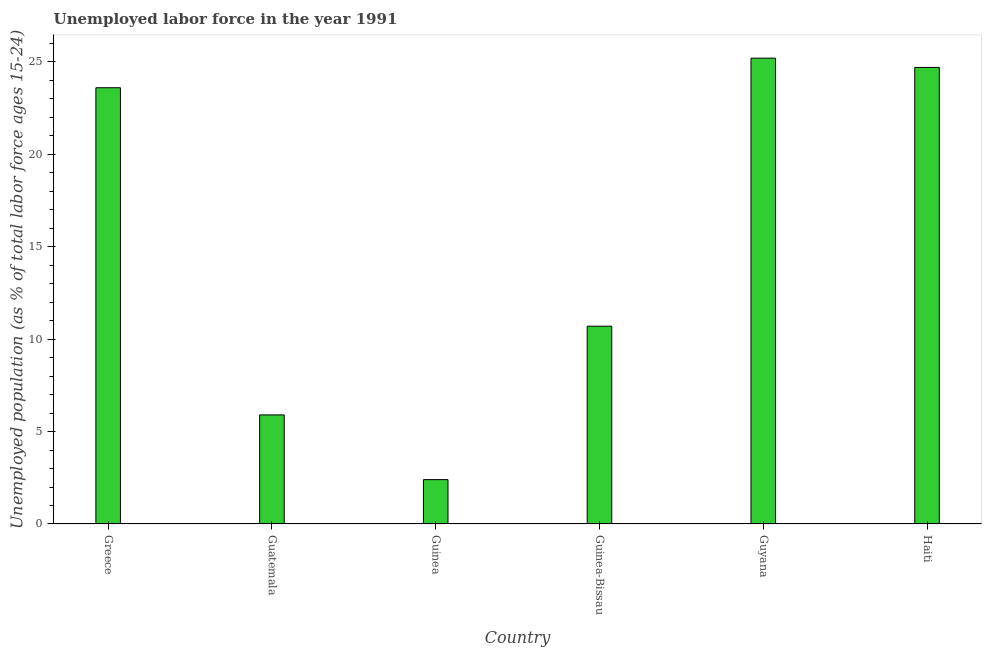Does the graph contain any zero values?
Make the answer very short. No. What is the title of the graph?
Make the answer very short. Unemployed labor force in the year 1991. What is the label or title of the Y-axis?
Provide a short and direct response. Unemployed population (as % of total labor force ages 15-24). What is the total unemployed youth population in Greece?
Make the answer very short. 23.6. Across all countries, what is the maximum total unemployed youth population?
Your answer should be very brief. 25.2. Across all countries, what is the minimum total unemployed youth population?
Your answer should be compact. 2.4. In which country was the total unemployed youth population maximum?
Give a very brief answer. Guyana. In which country was the total unemployed youth population minimum?
Make the answer very short. Guinea. What is the sum of the total unemployed youth population?
Keep it short and to the point. 92.5. What is the difference between the total unemployed youth population in Guyana and Haiti?
Keep it short and to the point. 0.5. What is the average total unemployed youth population per country?
Offer a terse response. 15.42. What is the median total unemployed youth population?
Give a very brief answer. 17.15. In how many countries, is the total unemployed youth population greater than 15 %?
Make the answer very short. 3. Is the sum of the total unemployed youth population in Guinea-Bissau and Haiti greater than the maximum total unemployed youth population across all countries?
Provide a succinct answer. Yes. What is the difference between the highest and the lowest total unemployed youth population?
Keep it short and to the point. 22.8. In how many countries, is the total unemployed youth population greater than the average total unemployed youth population taken over all countries?
Your answer should be very brief. 3. How many bars are there?
Keep it short and to the point. 6. Are all the bars in the graph horizontal?
Your response must be concise. No. What is the difference between two consecutive major ticks on the Y-axis?
Provide a short and direct response. 5. What is the Unemployed population (as % of total labor force ages 15-24) of Greece?
Ensure brevity in your answer.  23.6. What is the Unemployed population (as % of total labor force ages 15-24) in Guatemala?
Offer a terse response. 5.9. What is the Unemployed population (as % of total labor force ages 15-24) in Guinea?
Make the answer very short. 2.4. What is the Unemployed population (as % of total labor force ages 15-24) of Guinea-Bissau?
Give a very brief answer. 10.7. What is the Unemployed population (as % of total labor force ages 15-24) in Guyana?
Your response must be concise. 25.2. What is the Unemployed population (as % of total labor force ages 15-24) of Haiti?
Ensure brevity in your answer.  24.7. What is the difference between the Unemployed population (as % of total labor force ages 15-24) in Greece and Guinea?
Your answer should be very brief. 21.2. What is the difference between the Unemployed population (as % of total labor force ages 15-24) in Greece and Guinea-Bissau?
Keep it short and to the point. 12.9. What is the difference between the Unemployed population (as % of total labor force ages 15-24) in Greece and Haiti?
Provide a short and direct response. -1.1. What is the difference between the Unemployed population (as % of total labor force ages 15-24) in Guatemala and Guinea-Bissau?
Ensure brevity in your answer.  -4.8. What is the difference between the Unemployed population (as % of total labor force ages 15-24) in Guatemala and Guyana?
Keep it short and to the point. -19.3. What is the difference between the Unemployed population (as % of total labor force ages 15-24) in Guatemala and Haiti?
Provide a short and direct response. -18.8. What is the difference between the Unemployed population (as % of total labor force ages 15-24) in Guinea and Guinea-Bissau?
Make the answer very short. -8.3. What is the difference between the Unemployed population (as % of total labor force ages 15-24) in Guinea and Guyana?
Your answer should be very brief. -22.8. What is the difference between the Unemployed population (as % of total labor force ages 15-24) in Guinea and Haiti?
Provide a succinct answer. -22.3. What is the difference between the Unemployed population (as % of total labor force ages 15-24) in Guyana and Haiti?
Make the answer very short. 0.5. What is the ratio of the Unemployed population (as % of total labor force ages 15-24) in Greece to that in Guinea?
Make the answer very short. 9.83. What is the ratio of the Unemployed population (as % of total labor force ages 15-24) in Greece to that in Guinea-Bissau?
Give a very brief answer. 2.21. What is the ratio of the Unemployed population (as % of total labor force ages 15-24) in Greece to that in Guyana?
Make the answer very short. 0.94. What is the ratio of the Unemployed population (as % of total labor force ages 15-24) in Greece to that in Haiti?
Provide a succinct answer. 0.95. What is the ratio of the Unemployed population (as % of total labor force ages 15-24) in Guatemala to that in Guinea?
Your answer should be very brief. 2.46. What is the ratio of the Unemployed population (as % of total labor force ages 15-24) in Guatemala to that in Guinea-Bissau?
Provide a short and direct response. 0.55. What is the ratio of the Unemployed population (as % of total labor force ages 15-24) in Guatemala to that in Guyana?
Provide a short and direct response. 0.23. What is the ratio of the Unemployed population (as % of total labor force ages 15-24) in Guatemala to that in Haiti?
Provide a short and direct response. 0.24. What is the ratio of the Unemployed population (as % of total labor force ages 15-24) in Guinea to that in Guinea-Bissau?
Your answer should be very brief. 0.22. What is the ratio of the Unemployed population (as % of total labor force ages 15-24) in Guinea to that in Guyana?
Give a very brief answer. 0.1. What is the ratio of the Unemployed population (as % of total labor force ages 15-24) in Guinea to that in Haiti?
Provide a succinct answer. 0.1. What is the ratio of the Unemployed population (as % of total labor force ages 15-24) in Guinea-Bissau to that in Guyana?
Ensure brevity in your answer.  0.42. What is the ratio of the Unemployed population (as % of total labor force ages 15-24) in Guinea-Bissau to that in Haiti?
Make the answer very short. 0.43. 